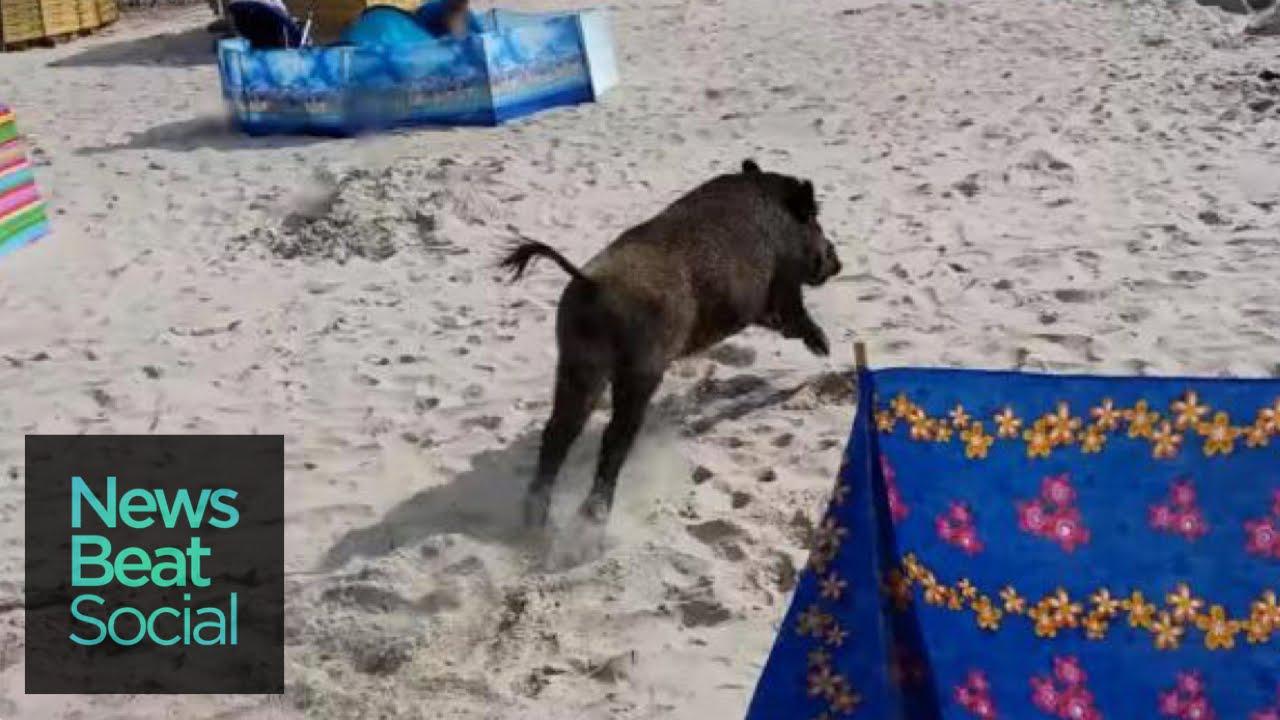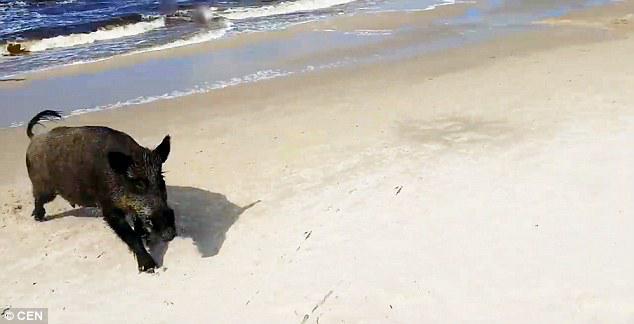The first image is the image on the left, the second image is the image on the right. For the images displayed, is the sentence "At least one pig is swimming through the water." factually correct? Answer yes or no. No. The first image is the image on the left, the second image is the image on the right. Given the left and right images, does the statement "Left image shows one wild hog that is lying in shallow water at the shoreline." hold true? Answer yes or no. No. 